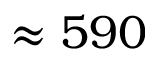Convert formula to latex. <formula><loc_0><loc_0><loc_500><loc_500>\approx 5 9 0</formula> 